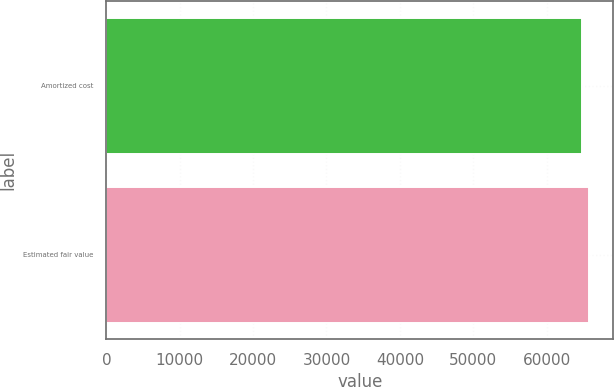Convert chart. <chart><loc_0><loc_0><loc_500><loc_500><bar_chart><fcel>Amortized cost<fcel>Estimated fair value<nl><fcel>64822<fcel>65824<nl></chart> 